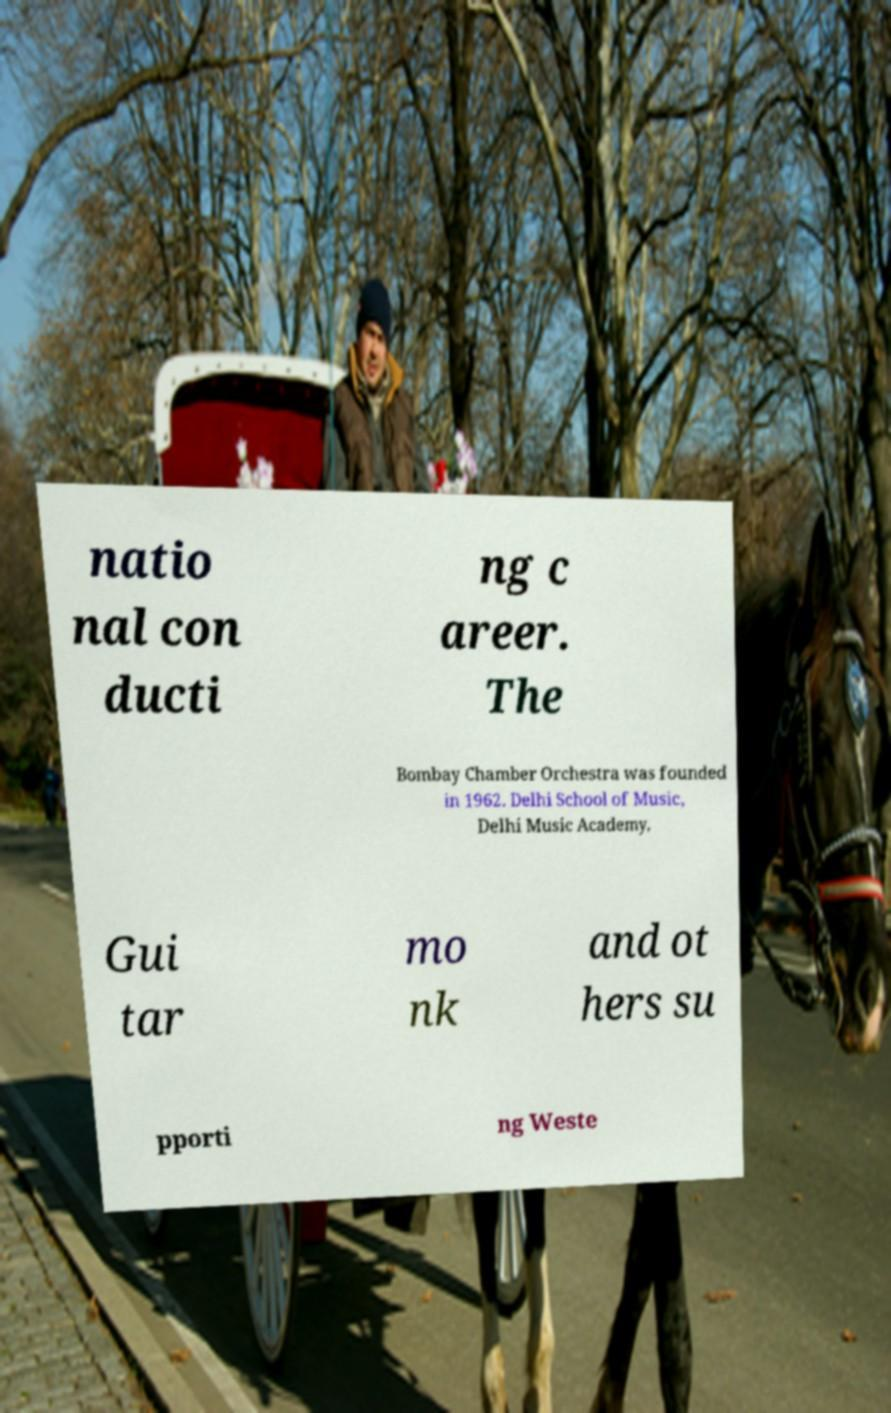There's text embedded in this image that I need extracted. Can you transcribe it verbatim? natio nal con ducti ng c areer. The Bombay Chamber Orchestra was founded in 1962. Delhi School of Music, Delhi Music Academy, Gui tar mo nk and ot hers su pporti ng Weste 